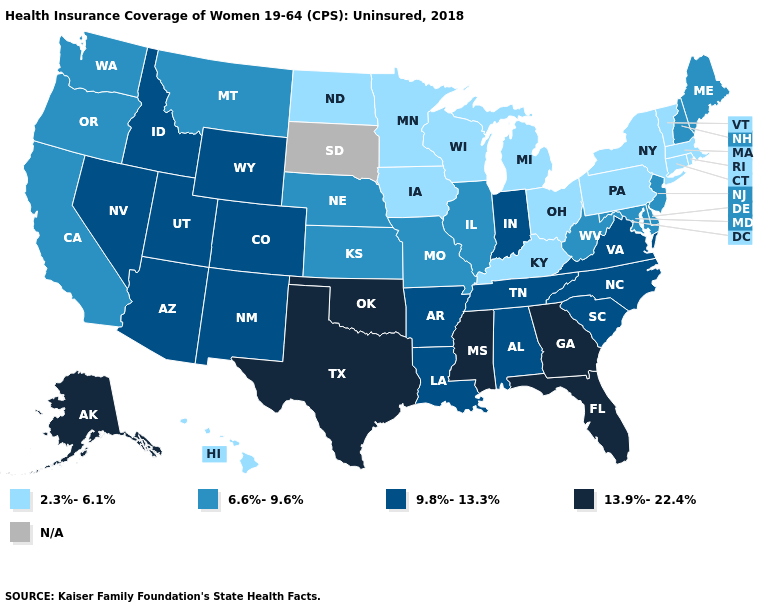Name the states that have a value in the range N/A?
Concise answer only. South Dakota. Which states have the highest value in the USA?
Answer briefly. Alaska, Florida, Georgia, Mississippi, Oklahoma, Texas. Among the states that border South Dakota , which have the lowest value?
Write a very short answer. Iowa, Minnesota, North Dakota. What is the value of Montana?
Concise answer only. 6.6%-9.6%. Name the states that have a value in the range 9.8%-13.3%?
Answer briefly. Alabama, Arizona, Arkansas, Colorado, Idaho, Indiana, Louisiana, Nevada, New Mexico, North Carolina, South Carolina, Tennessee, Utah, Virginia, Wyoming. Among the states that border Illinois , which have the highest value?
Concise answer only. Indiana. What is the highest value in the South ?
Short answer required. 13.9%-22.4%. Is the legend a continuous bar?
Give a very brief answer. No. Does Kentucky have the lowest value in the South?
Short answer required. Yes. Name the states that have a value in the range N/A?
Concise answer only. South Dakota. Name the states that have a value in the range N/A?
Quick response, please. South Dakota. What is the highest value in states that border Kansas?
Be succinct. 13.9%-22.4%. What is the lowest value in the USA?
Give a very brief answer. 2.3%-6.1%. What is the highest value in the West ?
Short answer required. 13.9%-22.4%. 